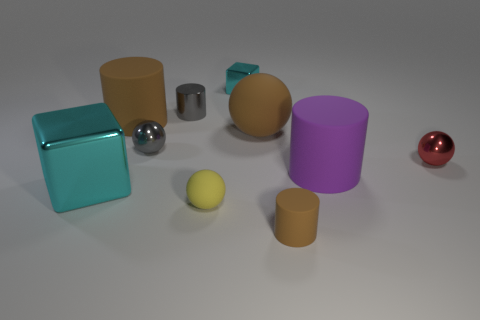Subtract all blue cubes. How many brown cylinders are left? 2 Subtract 2 cylinders. How many cylinders are left? 2 Subtract all yellow spheres. How many spheres are left? 3 Subtract all small shiny cylinders. How many cylinders are left? 3 Subtract all purple balls. Subtract all yellow cylinders. How many balls are left? 4 Subtract all cubes. How many objects are left? 8 Add 2 tiny things. How many tiny things exist? 8 Subtract 1 cyan blocks. How many objects are left? 9 Subtract all big matte spheres. Subtract all large brown things. How many objects are left? 7 Add 1 big brown spheres. How many big brown spheres are left? 2 